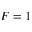Convert formula to latex. <formula><loc_0><loc_0><loc_500><loc_500>F = 1</formula> 